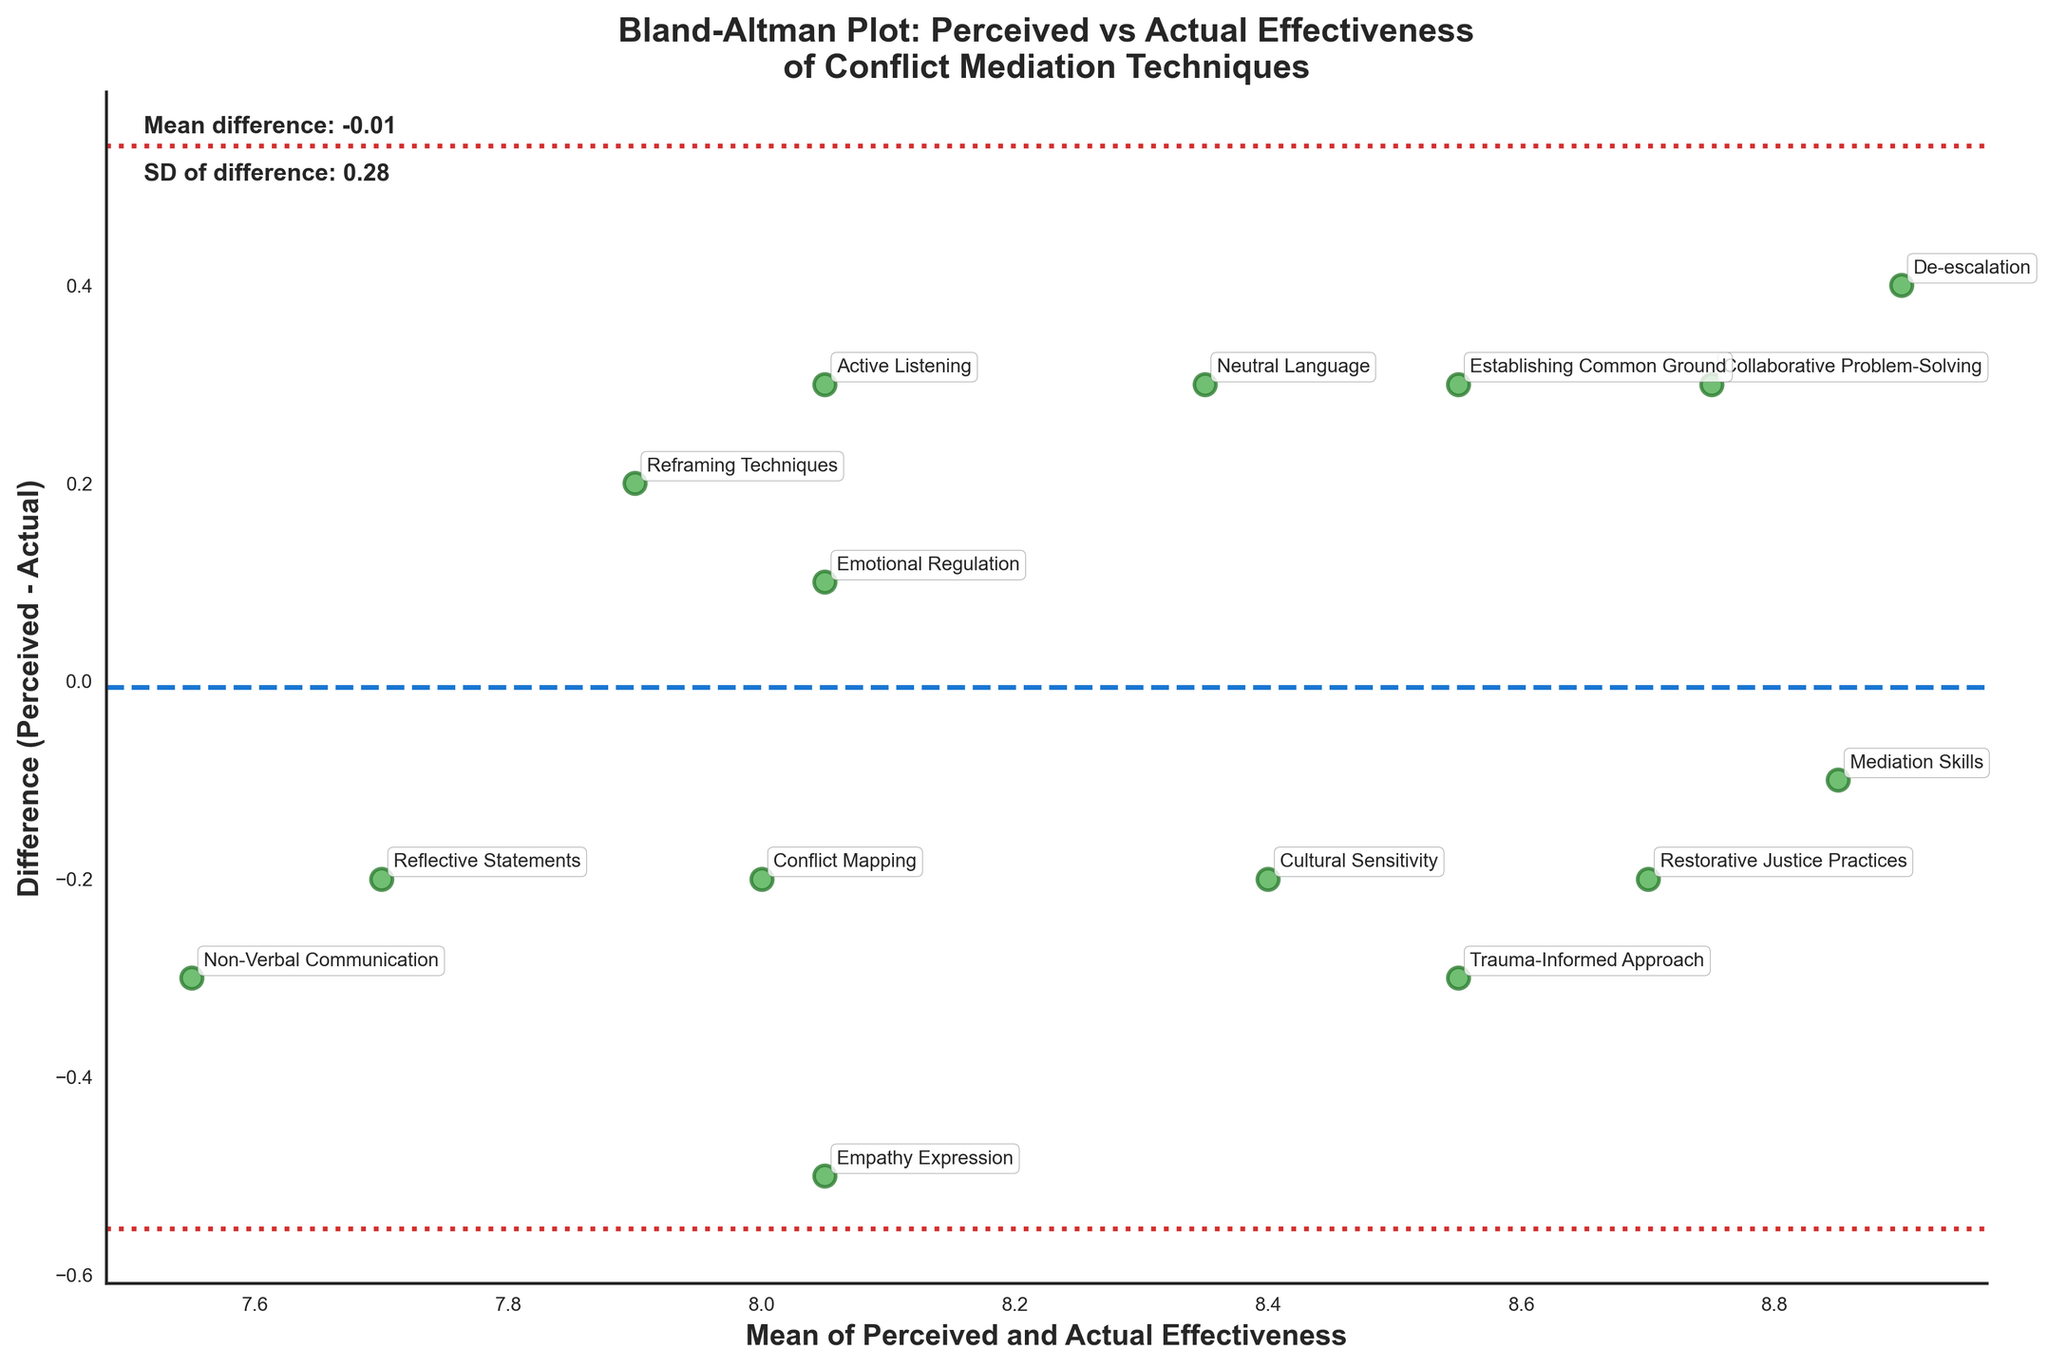What is the title of the plot? The title of the plot is usually located at the top and typically in a larger font size. In this case, it describes the main subject of the plot.
Answer: Bland-Altman Plot: Perceived vs Actual Effectiveness of Conflict Mediation Techniques How many data points are plotted in the figure? To determine the number of data points, you can count the individual markers (scatter points) in the plot. Each marker corresponds to a data point from the dataset.
Answer: 15 What do the dashed and dotted lines represent? The middle dashed line represents the mean difference between perceived and actual effectiveness. The dotted lines above and below represent the limits of agreement (mean difference ± 1.96 times the standard deviation).
Answer: Mean difference and limits of agreement Which technique has the greatest positive difference between perceived and actual effectiveness? By identifying the highest point on the vertical axis, we can see the technique label near that point. This indicates the greatest positive difference.
Answer: Empathy Expression What is the mean difference between perceived and actual effectiveness? The mean difference is indicated by the dashed horizontal line and the associated label, typically found in or near the plot. The corresponding numeric value can be read directly from the plot.
Answer: -0.04 Which technique's perceived effectiveness exactly matches its actual effectiveness? Look for a data point that lies on the x-axis (where the difference is zero). The label next to this point indicates the technique.
Answer: Mediation Skills What is the range of the mean of perceived and actual effectiveness values? The range can be determined by looking at the minimum and maximum values on the x-axis, which represents the mean of perceived and actual effectiveness.
Answer: 7.55 to 8.75 Which technique has the greatest negative difference between perceived and actual effectiveness? Identify the lowest point on the vertical axis and read the label next to that point. This indicates the greatest negative difference.
Answer: De-escalation What is the standard deviation of the differences between perceived and actual effectiveness? The standard deviation of the differences is typically labeled along with the mean difference on or near the plot area. This information can be directly read from the figure.
Answer: 0.27 